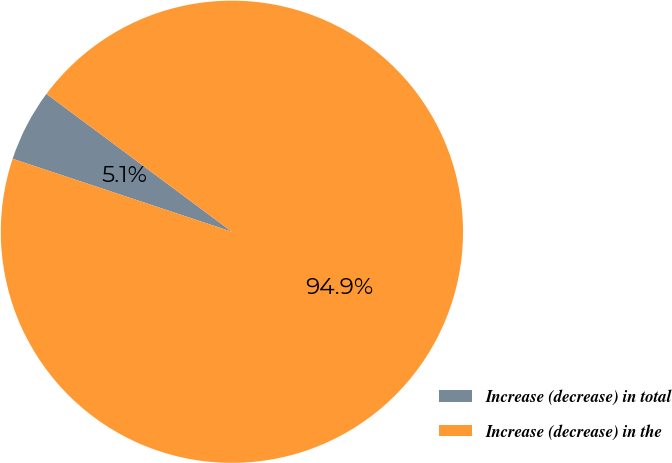Convert chart to OTSL. <chart><loc_0><loc_0><loc_500><loc_500><pie_chart><fcel>Increase (decrease) in total<fcel>Increase (decrease) in the<nl><fcel>5.06%<fcel>94.94%<nl></chart> 